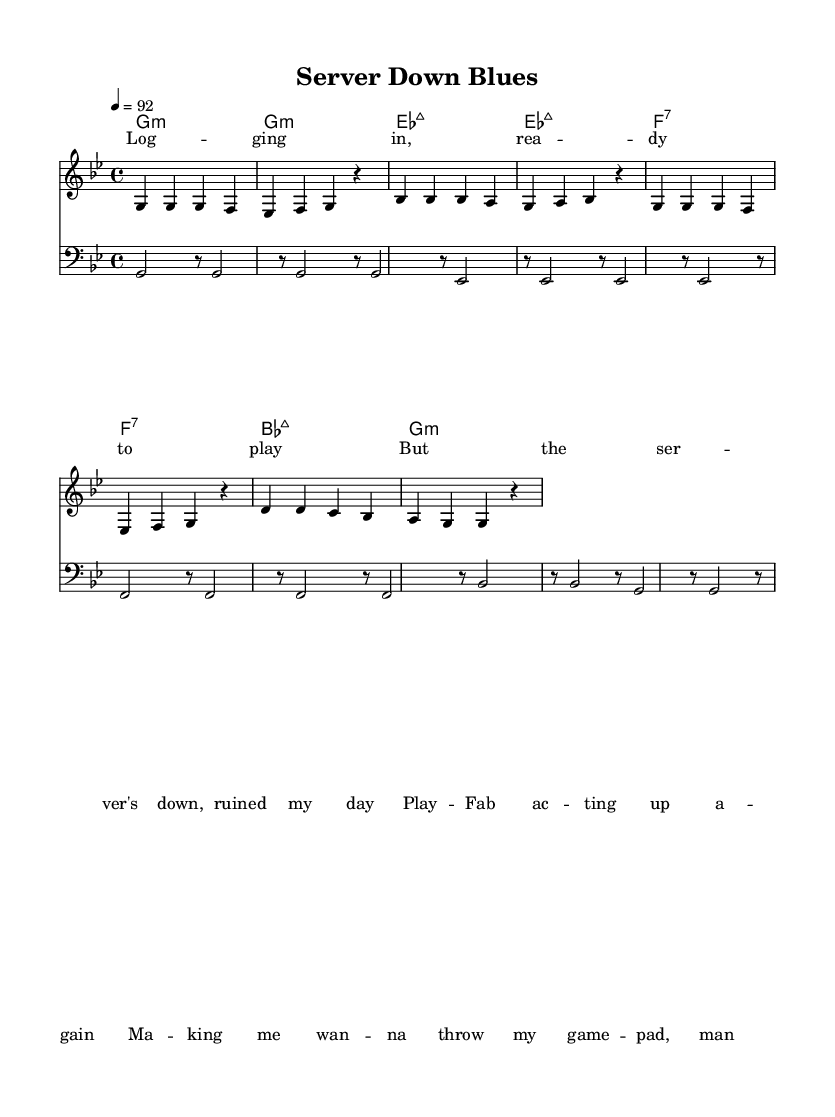What is the key signature of this music? The key signature is indicated by the key signature symbol at the beginning of the staff. In this case, there is a B flat and an E flat indicated, which corresponds to G minor.
Answer: G minor What is the time signature of this piece? The time signature is shown at the beginning of the staff, represented by the numbers on top of each other. Here, it is 4 over 4, indicating four beats in a measure.
Answer: 4/4 What tempo marking is given for the piece? The tempo marking is found at the beginning of the score and states a particular speed for the music. In this case, it indicates a tempo of 92 beats per minute.
Answer: 92 How many measures are in the melody? To find the number of measures, count the vertical lines that separate the measures in the melody staff. There are eight measures shown.
Answer: 8 How many different chords are used in the chord progression? By reviewing the chord names listed below the staff, we count each distinct chord represented. The progression features four different chords: G minor, E flat major 7, F 7, and B flat major 7.
Answer: 4 What is the primary theme of the lyrics? The lyrics convey a narrative about frustration with gaming platform issues, as indicated by phrases like "server's down" and "ruined my day."
Answer: Frustration with gaming Which part of the music contains the lyrics? In the score, the lyrics are notated in the section labeled "new Lyrics." They are placed directly above the melody staff, indicating they accompany the melodic line.
Answer: Above the melody 